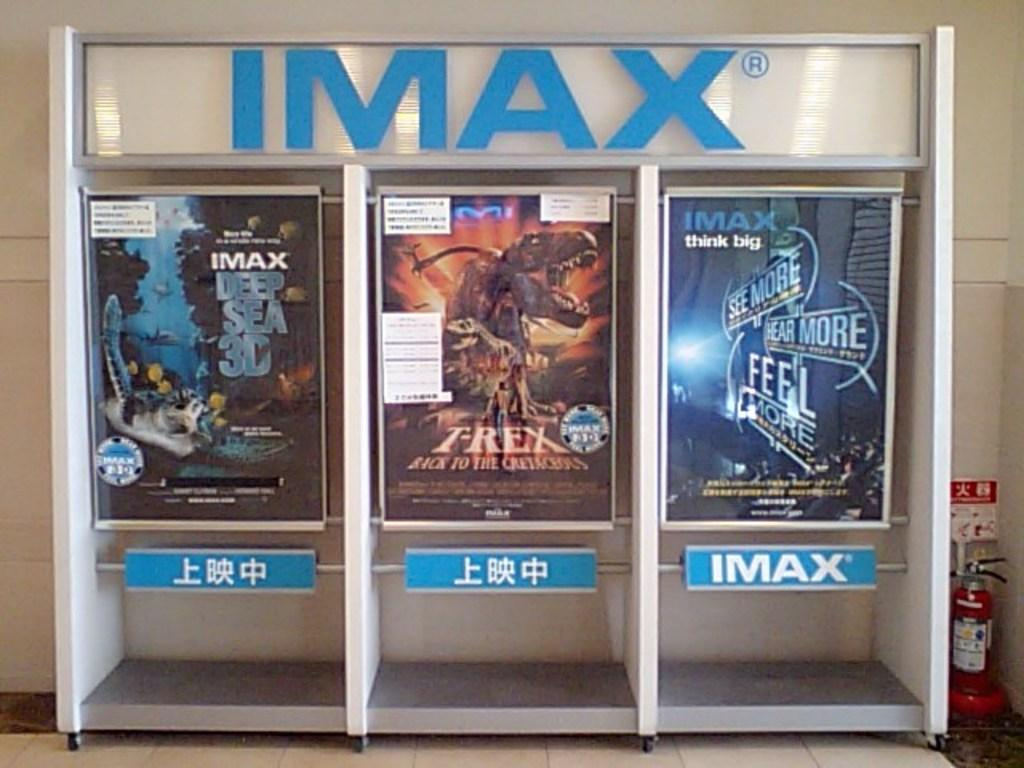<image>
Create a compact narrative representing the image presented. An imax advertisement with three movie posters, one being deep sea 3d. 